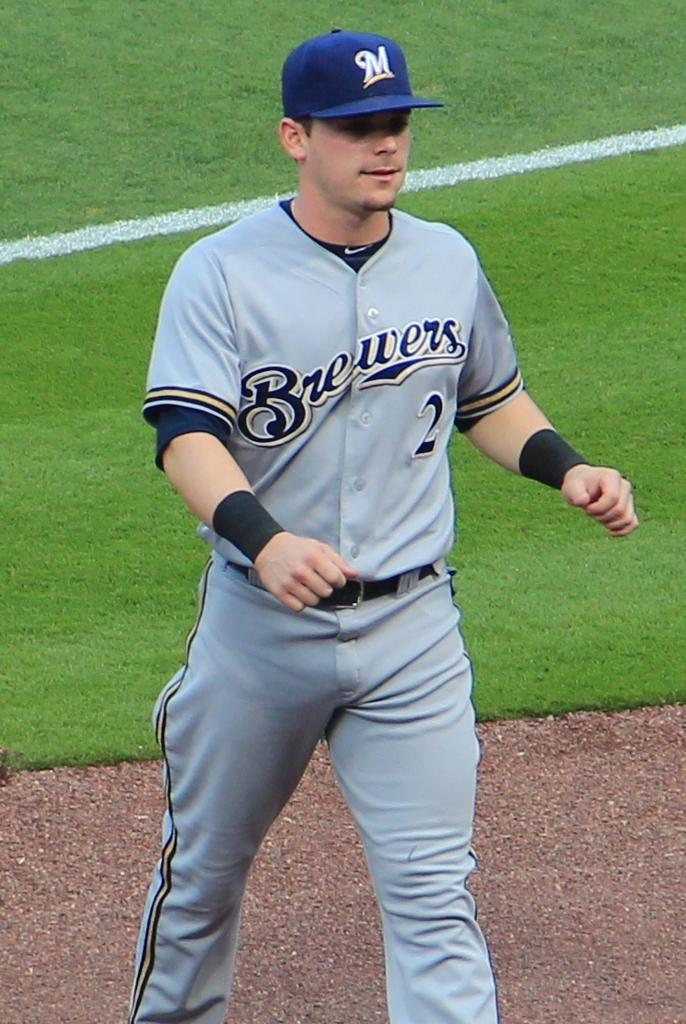<image>
Render a clear and concise summary of the photo. A baseball player for the Brewers walks on the field. 